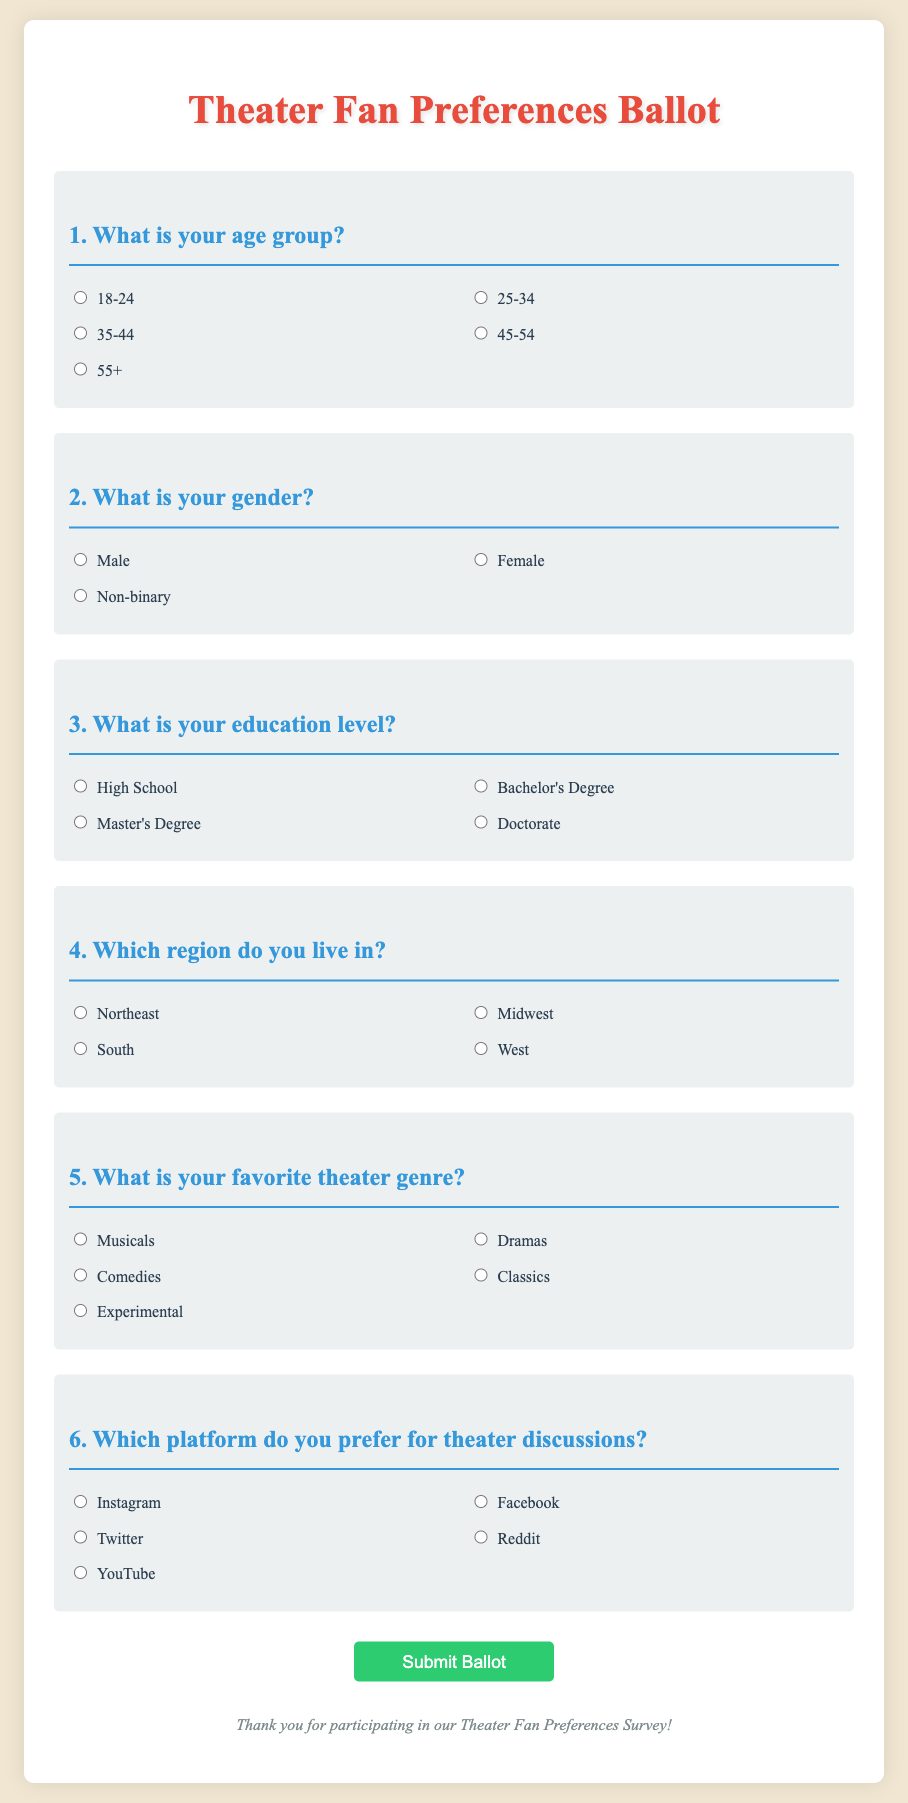What is the title of the document? The title of the document is displayed prominently at the top, naming the focus of the ballot.
Answer: Theater Fan Preferences Ballot How many age group options are provided in the ballot? The ballot lists five different age group options for respondents to choose from.
Answer: 5 What is the first question on the ballot? The first question in the document asks about the age group of the respondents.
Answer: What is your age group? Which gender option is included in the survey? The gender options available for selection in the ballot include three distinct categories.
Answer: Male, Female, Non-binary What is the preferred platform for theater discussions? The ballot presents five different platforms for respondents to indicate their preferences regarding discussion venues.
Answer: Instagram, Facebook, Twitter, Reddit, YouTube What education level option is NOT included in the ballot? The ballot presents a variety of education levels, but one level is missing from the options provided.
Answer: Associate's Degree What is the main purpose of the document? The document aims to gather preferences from theater fans regarding their demographics and engagement in discussions.
Answer: Theater fan preferences survey How many regions are listed for respondents to select from? The document provides options for respondents to indicate which of four regions they reside in.
Answer: 4 